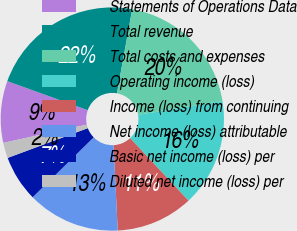Convert chart. <chart><loc_0><loc_0><loc_500><loc_500><pie_chart><fcel>Statements of Operations Data<fcel>Total revenue<fcel>Total costs and expenses<fcel>Operating income (loss)<fcel>Income (loss) from continuing<fcel>Net income (loss) attributable<fcel>Basic net income (loss) per<fcel>Diluted net income (loss) per<nl><fcel>8.94%<fcel>22.34%<fcel>19.56%<fcel>15.64%<fcel>11.17%<fcel>13.41%<fcel>6.7%<fcel>2.23%<nl></chart> 